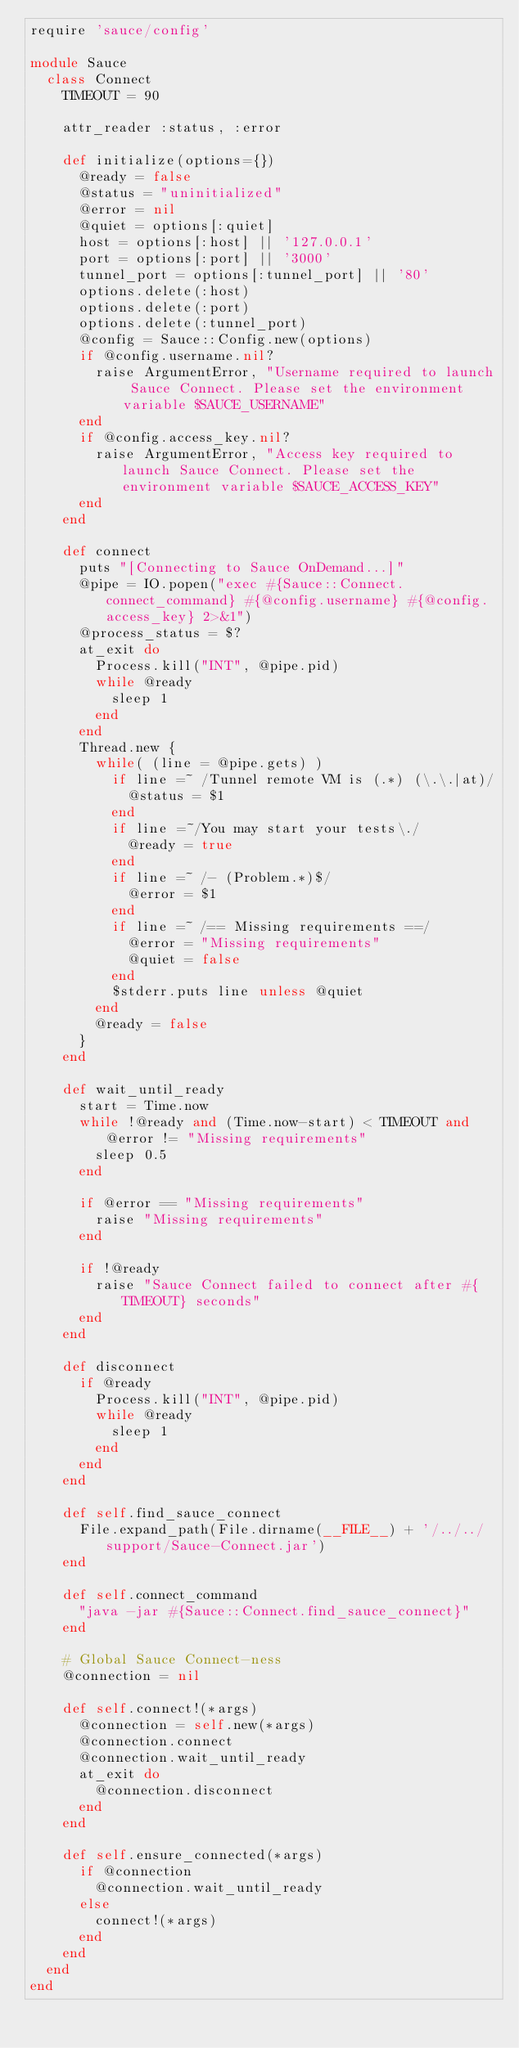<code> <loc_0><loc_0><loc_500><loc_500><_Ruby_>require 'sauce/config'

module Sauce
  class Connect
    TIMEOUT = 90

    attr_reader :status, :error

    def initialize(options={})
      @ready = false
      @status = "uninitialized"
      @error = nil
      @quiet = options[:quiet]
      host = options[:host] || '127.0.0.1'
      port = options[:port] || '3000'
      tunnel_port = options[:tunnel_port] || '80'
      options.delete(:host)
      options.delete(:port)
      options.delete(:tunnel_port)
      @config = Sauce::Config.new(options)
      if @config.username.nil?
        raise ArgumentError, "Username required to launch Sauce Connect. Please set the environment variable $SAUCE_USERNAME"
      end
      if @config.access_key.nil?
        raise ArgumentError, "Access key required to launch Sauce Connect. Please set the environment variable $SAUCE_ACCESS_KEY"
      end
    end

    def connect
      puts "[Connecting to Sauce OnDemand...]"
      @pipe = IO.popen("exec #{Sauce::Connect.connect_command} #{@config.username} #{@config.access_key} 2>&1")
      @process_status = $?
      at_exit do
        Process.kill("INT", @pipe.pid)
        while @ready
          sleep 1
        end
      end
      Thread.new {
        while( (line = @pipe.gets) )
          if line =~ /Tunnel remote VM is (.*) (\.\.|at)/
            @status = $1
          end
          if line =~/You may start your tests\./
            @ready = true
          end
          if line =~ /- (Problem.*)$/
            @error = $1
          end
          if line =~ /== Missing requirements ==/
            @error = "Missing requirements"
            @quiet = false
          end
          $stderr.puts line unless @quiet
        end
        @ready = false
      }
    end

    def wait_until_ready
      start = Time.now
      while !@ready and (Time.now-start) < TIMEOUT and @error != "Missing requirements"
        sleep 0.5
      end

      if @error == "Missing requirements"
        raise "Missing requirements"
      end

      if !@ready
        raise "Sauce Connect failed to connect after #{TIMEOUT} seconds"
      end
    end

    def disconnect
      if @ready
        Process.kill("INT", @pipe.pid)
        while @ready
          sleep 1
        end
      end
    end

    def self.find_sauce_connect
      File.expand_path(File.dirname(__FILE__) + '/../../support/Sauce-Connect.jar')
    end

    def self.connect_command
      "java -jar #{Sauce::Connect.find_sauce_connect}"
    end

    # Global Sauce Connect-ness
    @connection = nil

    def self.connect!(*args)
      @connection = self.new(*args)
      @connection.connect
      @connection.wait_until_ready
      at_exit do
        @connection.disconnect
      end
    end

    def self.ensure_connected(*args)
      if @connection
        @connection.wait_until_ready
      else
        connect!(*args)
      end
    end
  end
end
</code> 